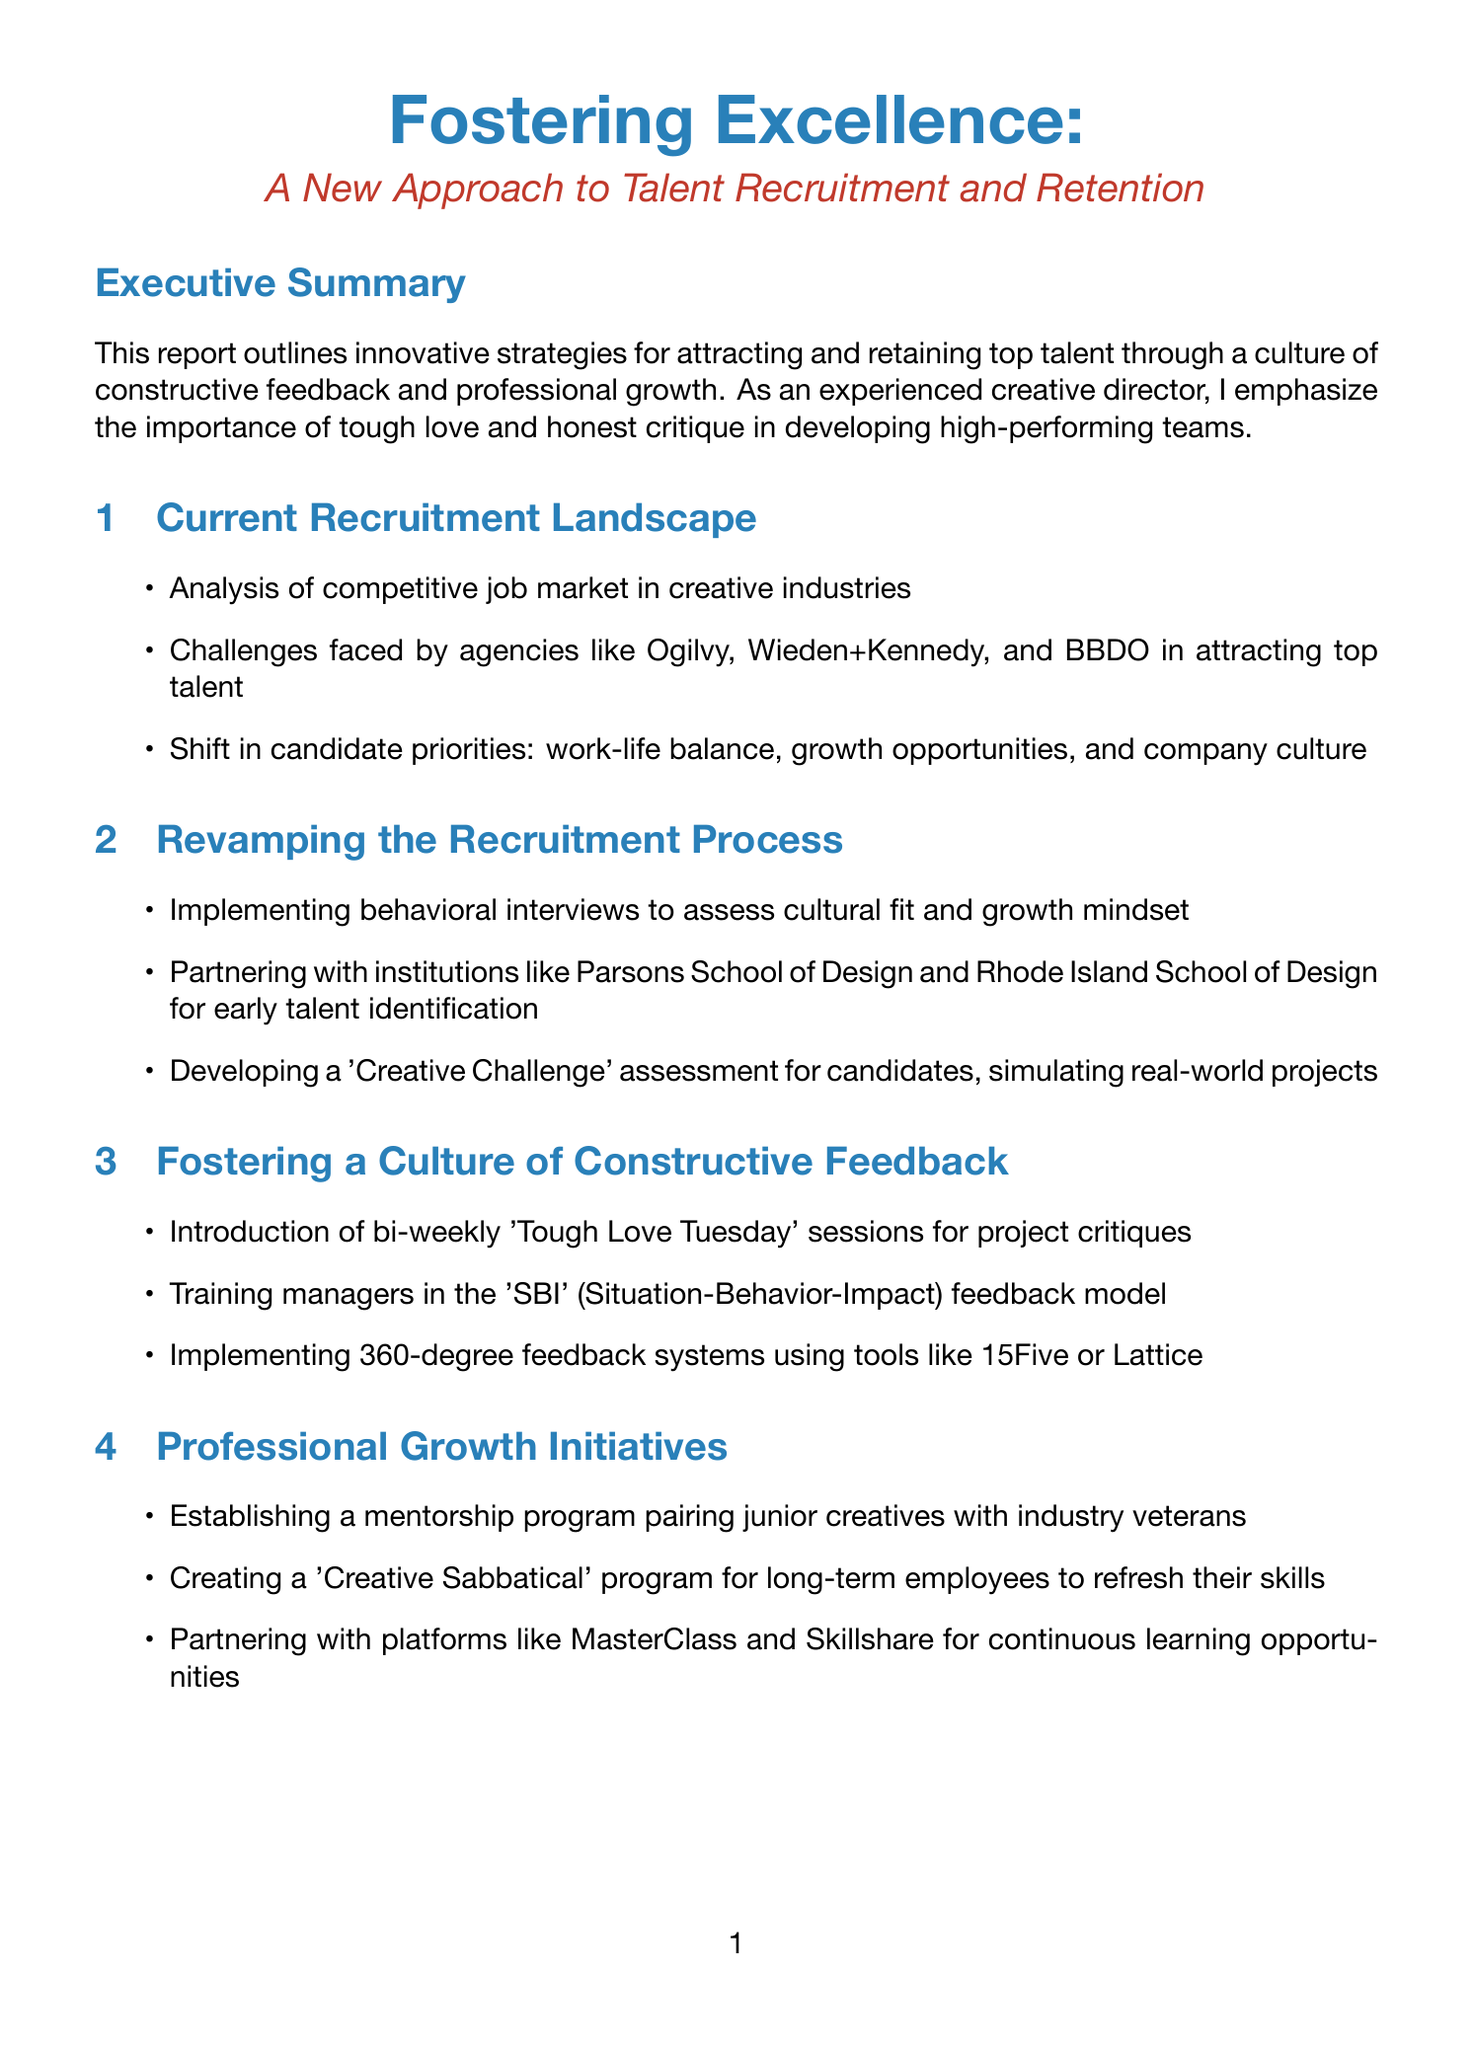What is the report title? The report title is presented at the beginning of the document, which is "Fostering Excellence: A New Approach to Talent Recruitment and Retention."
Answer: Fostering Excellence: A New Approach to Talent Recruitment and Retention What is the key focus of the report? The executive summary emphasizes the importance of a culture of constructive feedback and professional growth in talent recruitment and retention.
Answer: Constructive feedback and professional growth What are the three key phases in the implementation roadmap? The phases include leadership alignment and training, rollout of new recruitment strategies, and launch of professional growth initiatives.
Answer: Leadership alignment and training, rollout of new recruitment strategies, launch of professional growth initiatives Which company implemented a 'Fail Forward' program? The content includes case studies that highlight initiatives by various companies, specifically mentioning Droga5 for their 'Fail Forward' program.
Answer: Droga5 What feedback model will managers be trained in? The report states that managers will be trained in the 'SBI' feedback model, which stands for Situation-Behavior-Impact.
Answer: SBI What is the expected improvement in employee retention after R/GA's initiative? The case study regarding R/GA indicates a 15% improvement in employee retention as a result of their 'Creative Residency' program.
Answer: 15% When is the rollout of new recruitment strategies scheduled? The Implementation Roadmap indicates that the rollout will occur in Q4 2023.
Answer: Q4 2023 What is a key performance indicator mentioned in the report? The report lists several key performance indicators, with employee retention rate being one of them.
Answer: Employee retention rate 